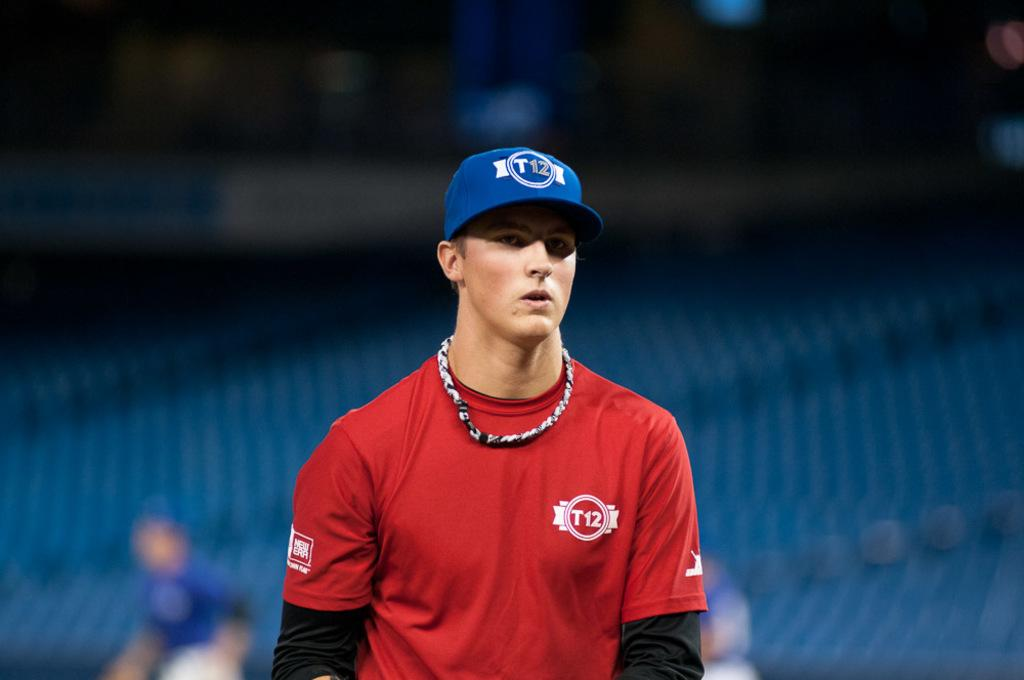<image>
Describe the image concisely. A young ball player wears a T12 cap. 